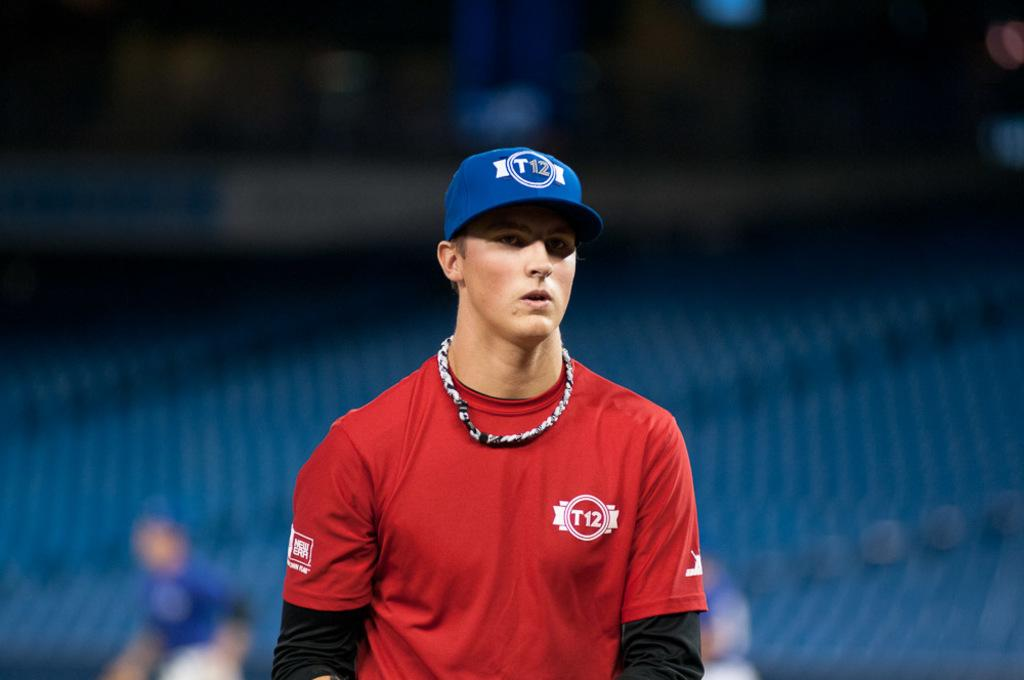Provide a one-sentence caption for the provided image. A young man wears a blue baseball hat with a red shirt and T12 in white letters on the upper left side of the shirt. 